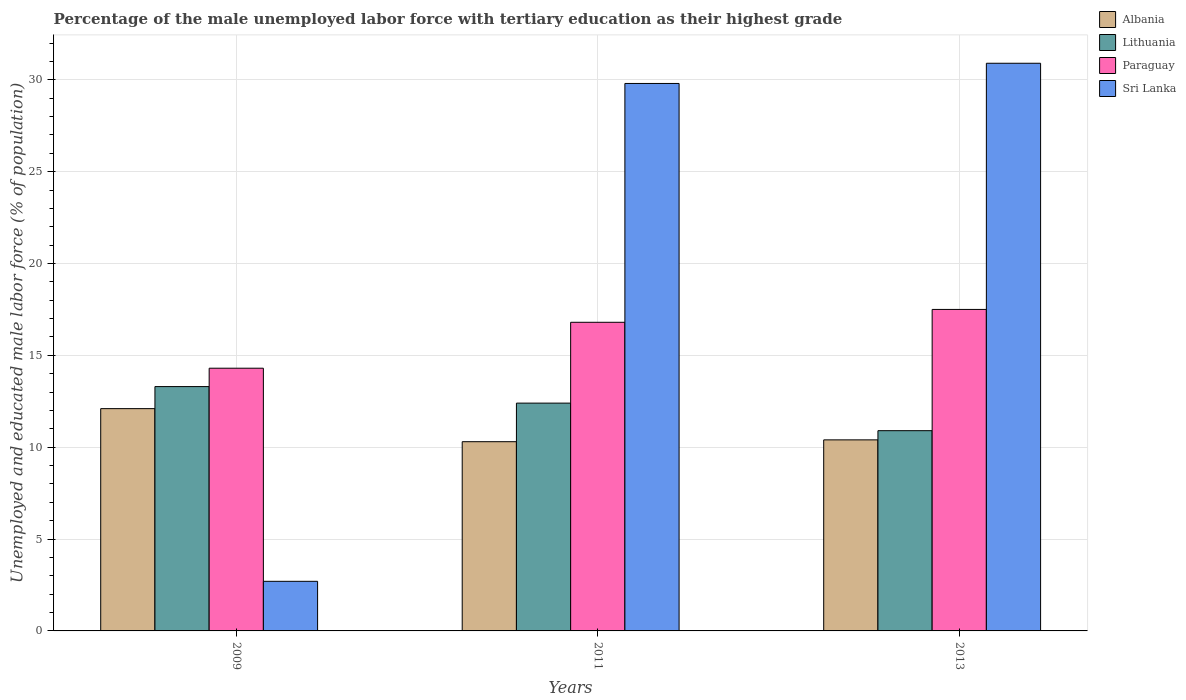How many groups of bars are there?
Your answer should be compact. 3. Are the number of bars per tick equal to the number of legend labels?
Your answer should be very brief. Yes. Are the number of bars on each tick of the X-axis equal?
Keep it short and to the point. Yes. How many bars are there on the 1st tick from the right?
Your answer should be compact. 4. What is the label of the 1st group of bars from the left?
Keep it short and to the point. 2009. What is the percentage of the unemployed male labor force with tertiary education in Paraguay in 2011?
Give a very brief answer. 16.8. Across all years, what is the maximum percentage of the unemployed male labor force with tertiary education in Sri Lanka?
Offer a terse response. 30.9. Across all years, what is the minimum percentage of the unemployed male labor force with tertiary education in Albania?
Make the answer very short. 10.3. In which year was the percentage of the unemployed male labor force with tertiary education in Sri Lanka maximum?
Your answer should be very brief. 2013. What is the total percentage of the unemployed male labor force with tertiary education in Sri Lanka in the graph?
Offer a very short reply. 63.4. What is the difference between the percentage of the unemployed male labor force with tertiary education in Albania in 2009 and that in 2011?
Offer a very short reply. 1.8. What is the difference between the percentage of the unemployed male labor force with tertiary education in Paraguay in 2009 and the percentage of the unemployed male labor force with tertiary education in Sri Lanka in 2013?
Keep it short and to the point. -16.6. What is the average percentage of the unemployed male labor force with tertiary education in Sri Lanka per year?
Keep it short and to the point. 21.13. In the year 2013, what is the difference between the percentage of the unemployed male labor force with tertiary education in Sri Lanka and percentage of the unemployed male labor force with tertiary education in Albania?
Your answer should be very brief. 20.5. What is the ratio of the percentage of the unemployed male labor force with tertiary education in Paraguay in 2009 to that in 2011?
Provide a succinct answer. 0.85. Is the percentage of the unemployed male labor force with tertiary education in Lithuania in 2009 less than that in 2011?
Ensure brevity in your answer.  No. What is the difference between the highest and the second highest percentage of the unemployed male labor force with tertiary education in Sri Lanka?
Provide a short and direct response. 1.1. What is the difference between the highest and the lowest percentage of the unemployed male labor force with tertiary education in Lithuania?
Your response must be concise. 2.4. Is the sum of the percentage of the unemployed male labor force with tertiary education in Albania in 2009 and 2011 greater than the maximum percentage of the unemployed male labor force with tertiary education in Paraguay across all years?
Ensure brevity in your answer.  Yes. Is it the case that in every year, the sum of the percentage of the unemployed male labor force with tertiary education in Paraguay and percentage of the unemployed male labor force with tertiary education in Sri Lanka is greater than the sum of percentage of the unemployed male labor force with tertiary education in Albania and percentage of the unemployed male labor force with tertiary education in Lithuania?
Provide a succinct answer. No. What does the 4th bar from the left in 2011 represents?
Keep it short and to the point. Sri Lanka. What does the 2nd bar from the right in 2011 represents?
Your response must be concise. Paraguay. Is it the case that in every year, the sum of the percentage of the unemployed male labor force with tertiary education in Lithuania and percentage of the unemployed male labor force with tertiary education in Albania is greater than the percentage of the unemployed male labor force with tertiary education in Paraguay?
Make the answer very short. Yes. What is the difference between two consecutive major ticks on the Y-axis?
Ensure brevity in your answer.  5. How many legend labels are there?
Provide a short and direct response. 4. What is the title of the graph?
Provide a succinct answer. Percentage of the male unemployed labor force with tertiary education as their highest grade. Does "Burkina Faso" appear as one of the legend labels in the graph?
Offer a very short reply. No. What is the label or title of the X-axis?
Offer a very short reply. Years. What is the label or title of the Y-axis?
Ensure brevity in your answer.  Unemployed and educated male labor force (% of population). What is the Unemployed and educated male labor force (% of population) in Albania in 2009?
Your answer should be compact. 12.1. What is the Unemployed and educated male labor force (% of population) in Lithuania in 2009?
Keep it short and to the point. 13.3. What is the Unemployed and educated male labor force (% of population) in Paraguay in 2009?
Offer a terse response. 14.3. What is the Unemployed and educated male labor force (% of population) in Sri Lanka in 2009?
Offer a terse response. 2.7. What is the Unemployed and educated male labor force (% of population) of Albania in 2011?
Provide a short and direct response. 10.3. What is the Unemployed and educated male labor force (% of population) in Lithuania in 2011?
Provide a succinct answer. 12.4. What is the Unemployed and educated male labor force (% of population) in Paraguay in 2011?
Make the answer very short. 16.8. What is the Unemployed and educated male labor force (% of population) in Sri Lanka in 2011?
Provide a succinct answer. 29.8. What is the Unemployed and educated male labor force (% of population) in Albania in 2013?
Provide a succinct answer. 10.4. What is the Unemployed and educated male labor force (% of population) in Lithuania in 2013?
Your answer should be very brief. 10.9. What is the Unemployed and educated male labor force (% of population) in Sri Lanka in 2013?
Offer a terse response. 30.9. Across all years, what is the maximum Unemployed and educated male labor force (% of population) in Albania?
Give a very brief answer. 12.1. Across all years, what is the maximum Unemployed and educated male labor force (% of population) of Lithuania?
Your answer should be compact. 13.3. Across all years, what is the maximum Unemployed and educated male labor force (% of population) in Paraguay?
Your response must be concise. 17.5. Across all years, what is the maximum Unemployed and educated male labor force (% of population) in Sri Lanka?
Your answer should be compact. 30.9. Across all years, what is the minimum Unemployed and educated male labor force (% of population) in Albania?
Offer a terse response. 10.3. Across all years, what is the minimum Unemployed and educated male labor force (% of population) in Lithuania?
Keep it short and to the point. 10.9. Across all years, what is the minimum Unemployed and educated male labor force (% of population) in Paraguay?
Offer a very short reply. 14.3. Across all years, what is the minimum Unemployed and educated male labor force (% of population) of Sri Lanka?
Your response must be concise. 2.7. What is the total Unemployed and educated male labor force (% of population) of Albania in the graph?
Your response must be concise. 32.8. What is the total Unemployed and educated male labor force (% of population) of Lithuania in the graph?
Offer a very short reply. 36.6. What is the total Unemployed and educated male labor force (% of population) in Paraguay in the graph?
Your response must be concise. 48.6. What is the total Unemployed and educated male labor force (% of population) in Sri Lanka in the graph?
Your answer should be compact. 63.4. What is the difference between the Unemployed and educated male labor force (% of population) of Lithuania in 2009 and that in 2011?
Keep it short and to the point. 0.9. What is the difference between the Unemployed and educated male labor force (% of population) in Sri Lanka in 2009 and that in 2011?
Your answer should be compact. -27.1. What is the difference between the Unemployed and educated male labor force (% of population) of Sri Lanka in 2009 and that in 2013?
Provide a succinct answer. -28.2. What is the difference between the Unemployed and educated male labor force (% of population) of Paraguay in 2011 and that in 2013?
Keep it short and to the point. -0.7. What is the difference between the Unemployed and educated male labor force (% of population) in Albania in 2009 and the Unemployed and educated male labor force (% of population) in Lithuania in 2011?
Offer a very short reply. -0.3. What is the difference between the Unemployed and educated male labor force (% of population) of Albania in 2009 and the Unemployed and educated male labor force (% of population) of Paraguay in 2011?
Offer a very short reply. -4.7. What is the difference between the Unemployed and educated male labor force (% of population) in Albania in 2009 and the Unemployed and educated male labor force (% of population) in Sri Lanka in 2011?
Ensure brevity in your answer.  -17.7. What is the difference between the Unemployed and educated male labor force (% of population) in Lithuania in 2009 and the Unemployed and educated male labor force (% of population) in Paraguay in 2011?
Ensure brevity in your answer.  -3.5. What is the difference between the Unemployed and educated male labor force (% of population) in Lithuania in 2009 and the Unemployed and educated male labor force (% of population) in Sri Lanka in 2011?
Offer a very short reply. -16.5. What is the difference between the Unemployed and educated male labor force (% of population) of Paraguay in 2009 and the Unemployed and educated male labor force (% of population) of Sri Lanka in 2011?
Offer a very short reply. -15.5. What is the difference between the Unemployed and educated male labor force (% of population) of Albania in 2009 and the Unemployed and educated male labor force (% of population) of Lithuania in 2013?
Your response must be concise. 1.2. What is the difference between the Unemployed and educated male labor force (% of population) of Albania in 2009 and the Unemployed and educated male labor force (% of population) of Sri Lanka in 2013?
Offer a terse response. -18.8. What is the difference between the Unemployed and educated male labor force (% of population) in Lithuania in 2009 and the Unemployed and educated male labor force (% of population) in Sri Lanka in 2013?
Offer a very short reply. -17.6. What is the difference between the Unemployed and educated male labor force (% of population) in Paraguay in 2009 and the Unemployed and educated male labor force (% of population) in Sri Lanka in 2013?
Offer a very short reply. -16.6. What is the difference between the Unemployed and educated male labor force (% of population) of Albania in 2011 and the Unemployed and educated male labor force (% of population) of Sri Lanka in 2013?
Your answer should be very brief. -20.6. What is the difference between the Unemployed and educated male labor force (% of population) of Lithuania in 2011 and the Unemployed and educated male labor force (% of population) of Paraguay in 2013?
Offer a very short reply. -5.1. What is the difference between the Unemployed and educated male labor force (% of population) of Lithuania in 2011 and the Unemployed and educated male labor force (% of population) of Sri Lanka in 2013?
Your response must be concise. -18.5. What is the difference between the Unemployed and educated male labor force (% of population) in Paraguay in 2011 and the Unemployed and educated male labor force (% of population) in Sri Lanka in 2013?
Your response must be concise. -14.1. What is the average Unemployed and educated male labor force (% of population) in Albania per year?
Keep it short and to the point. 10.93. What is the average Unemployed and educated male labor force (% of population) in Lithuania per year?
Your answer should be very brief. 12.2. What is the average Unemployed and educated male labor force (% of population) in Sri Lanka per year?
Your response must be concise. 21.13. In the year 2009, what is the difference between the Unemployed and educated male labor force (% of population) in Albania and Unemployed and educated male labor force (% of population) in Paraguay?
Provide a short and direct response. -2.2. In the year 2009, what is the difference between the Unemployed and educated male labor force (% of population) in Paraguay and Unemployed and educated male labor force (% of population) in Sri Lanka?
Your answer should be compact. 11.6. In the year 2011, what is the difference between the Unemployed and educated male labor force (% of population) of Albania and Unemployed and educated male labor force (% of population) of Lithuania?
Give a very brief answer. -2.1. In the year 2011, what is the difference between the Unemployed and educated male labor force (% of population) of Albania and Unemployed and educated male labor force (% of population) of Sri Lanka?
Provide a succinct answer. -19.5. In the year 2011, what is the difference between the Unemployed and educated male labor force (% of population) of Lithuania and Unemployed and educated male labor force (% of population) of Paraguay?
Provide a short and direct response. -4.4. In the year 2011, what is the difference between the Unemployed and educated male labor force (% of population) in Lithuania and Unemployed and educated male labor force (% of population) in Sri Lanka?
Keep it short and to the point. -17.4. In the year 2013, what is the difference between the Unemployed and educated male labor force (% of population) in Albania and Unemployed and educated male labor force (% of population) in Lithuania?
Your response must be concise. -0.5. In the year 2013, what is the difference between the Unemployed and educated male labor force (% of population) of Albania and Unemployed and educated male labor force (% of population) of Paraguay?
Provide a short and direct response. -7.1. In the year 2013, what is the difference between the Unemployed and educated male labor force (% of population) in Albania and Unemployed and educated male labor force (% of population) in Sri Lanka?
Make the answer very short. -20.5. In the year 2013, what is the difference between the Unemployed and educated male labor force (% of population) of Lithuania and Unemployed and educated male labor force (% of population) of Paraguay?
Offer a terse response. -6.6. In the year 2013, what is the difference between the Unemployed and educated male labor force (% of population) in Paraguay and Unemployed and educated male labor force (% of population) in Sri Lanka?
Give a very brief answer. -13.4. What is the ratio of the Unemployed and educated male labor force (% of population) of Albania in 2009 to that in 2011?
Ensure brevity in your answer.  1.17. What is the ratio of the Unemployed and educated male labor force (% of population) in Lithuania in 2009 to that in 2011?
Keep it short and to the point. 1.07. What is the ratio of the Unemployed and educated male labor force (% of population) in Paraguay in 2009 to that in 2011?
Provide a succinct answer. 0.85. What is the ratio of the Unemployed and educated male labor force (% of population) in Sri Lanka in 2009 to that in 2011?
Provide a succinct answer. 0.09. What is the ratio of the Unemployed and educated male labor force (% of population) in Albania in 2009 to that in 2013?
Provide a short and direct response. 1.16. What is the ratio of the Unemployed and educated male labor force (% of population) in Lithuania in 2009 to that in 2013?
Provide a succinct answer. 1.22. What is the ratio of the Unemployed and educated male labor force (% of population) in Paraguay in 2009 to that in 2013?
Provide a succinct answer. 0.82. What is the ratio of the Unemployed and educated male labor force (% of population) in Sri Lanka in 2009 to that in 2013?
Offer a very short reply. 0.09. What is the ratio of the Unemployed and educated male labor force (% of population) in Lithuania in 2011 to that in 2013?
Keep it short and to the point. 1.14. What is the ratio of the Unemployed and educated male labor force (% of population) of Sri Lanka in 2011 to that in 2013?
Offer a terse response. 0.96. What is the difference between the highest and the second highest Unemployed and educated male labor force (% of population) of Albania?
Your answer should be compact. 1.7. What is the difference between the highest and the second highest Unemployed and educated male labor force (% of population) of Lithuania?
Give a very brief answer. 0.9. What is the difference between the highest and the second highest Unemployed and educated male labor force (% of population) of Paraguay?
Your response must be concise. 0.7. What is the difference between the highest and the second highest Unemployed and educated male labor force (% of population) of Sri Lanka?
Offer a terse response. 1.1. What is the difference between the highest and the lowest Unemployed and educated male labor force (% of population) of Albania?
Provide a succinct answer. 1.8. What is the difference between the highest and the lowest Unemployed and educated male labor force (% of population) in Lithuania?
Keep it short and to the point. 2.4. What is the difference between the highest and the lowest Unemployed and educated male labor force (% of population) of Paraguay?
Give a very brief answer. 3.2. What is the difference between the highest and the lowest Unemployed and educated male labor force (% of population) of Sri Lanka?
Your answer should be very brief. 28.2. 